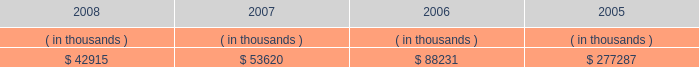System energy resources , inc .
Management's financial discussion and analysis with syndicated bank letters of credit .
In december 2004 , system energy amended these letters of credit and they now expire in may 2009 .
System energy may refinance or redeem debt prior to maturity , to the extent market conditions and interest and dividend rates are favorable .
All debt and common stock issuances by system energy require prior regulatory approval .
Debt issuances are also subject to issuance tests set forth in its bond indentures and other agreements .
System energy has sufficient capacity under these tests to meet its foreseeable capital needs .
System energy has obtained a short-term borrowing authorization from the ferc under which it may borrow , through march 31 , 2010 , up to the aggregate amount , at any one time outstanding , of $ 200 million .
See note 4 to the financial statements for further discussion of system energy's short-term borrowing limits .
System energy has also obtained an order from the ferc authorizing long-term securities issuances .
The current long- term authorization extends through june 2009 .
System energy's receivables from the money pool were as follows as of december 31 for each of the following years: .
In may 2007 , $ 22.5 million of system energy's receivable from the money pool was replaced by a note receivable from entergy new orleans .
See note 4 to the financial statements for a description of the money pool .
Nuclear matters system energy owns and operates grand gulf .
System energy is , therefore , subject to the risks related to owning and operating a nuclear plant .
These include risks from the use , storage , handling and disposal of high-level and low-level radioactive materials , regulatory requirement changes , including changes resulting from events at other plants , limitations on the amounts and types of insurance commercially available for losses in connection with nuclear operations , and technological and financial uncertainties related to decommissioning nuclear plants at the end of their licensed lives , including the sufficiency of funds in decommissioning trusts .
In the event of an unanticipated early shutdown of grand gulf , system energy may be required to provide additional funds or credit support to satisfy regulatory requirements for decommissioning .
Environmental risks system energy's facilities and operations are subject to regulation by various governmental authorities having jurisdiction over air quality , water quality , control of toxic substances and hazardous and solid wastes , and other environmental matters .
Management believes that system energy is in substantial compliance with environmental regulations currently applicable to its facilities and operations .
Because environmental regulations are subject to change , future compliance costs cannot be precisely estimated .
Critical accounting estimates the preparation of system energy's financial statements in conformity with generally accepted accounting principles requires management to apply appropriate accounting policies and to make estimates and judgments that .
What is the percent change in receivables from the money pool between 2007 and 2008? 
Computations: ((53620 - 42915) / 42915)
Answer: 0.24945. 